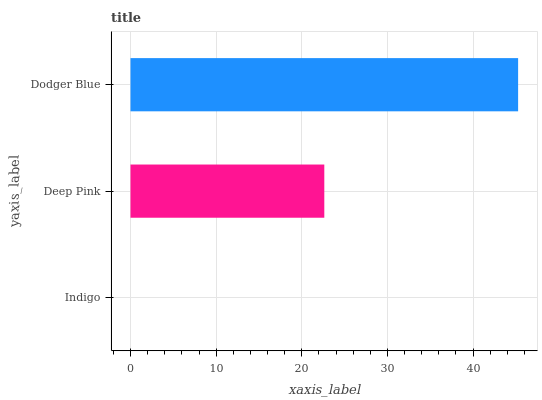Is Indigo the minimum?
Answer yes or no. Yes. Is Dodger Blue the maximum?
Answer yes or no. Yes. Is Deep Pink the minimum?
Answer yes or no. No. Is Deep Pink the maximum?
Answer yes or no. No. Is Deep Pink greater than Indigo?
Answer yes or no. Yes. Is Indigo less than Deep Pink?
Answer yes or no. Yes. Is Indigo greater than Deep Pink?
Answer yes or no. No. Is Deep Pink less than Indigo?
Answer yes or no. No. Is Deep Pink the high median?
Answer yes or no. Yes. Is Deep Pink the low median?
Answer yes or no. Yes. Is Indigo the high median?
Answer yes or no. No. Is Dodger Blue the low median?
Answer yes or no. No. 